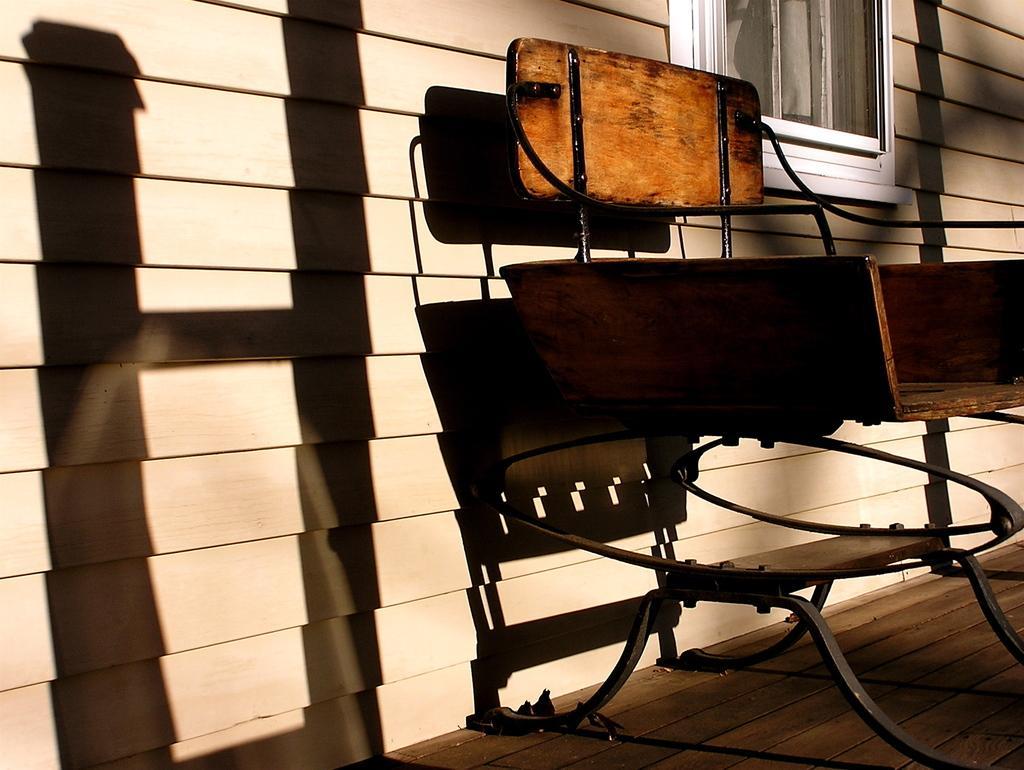Can you describe this image briefly? This picture seems to be clicked outside. On the right there is a wooden chair placed on the ground. In the background we can see the wooden planks and the window and we can see the shadow of chair and some objects on the planks. 